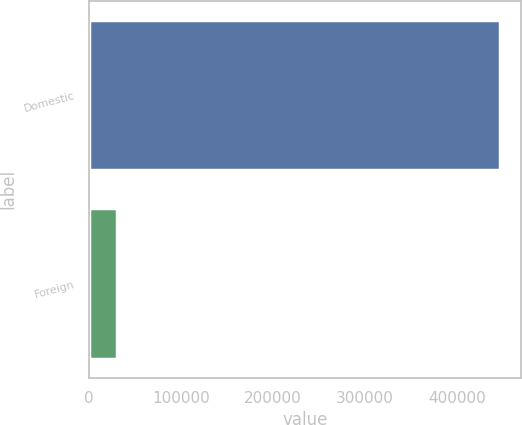<chart> <loc_0><loc_0><loc_500><loc_500><bar_chart><fcel>Domestic<fcel>Foreign<nl><fcel>446760<fcel>30498<nl></chart> 